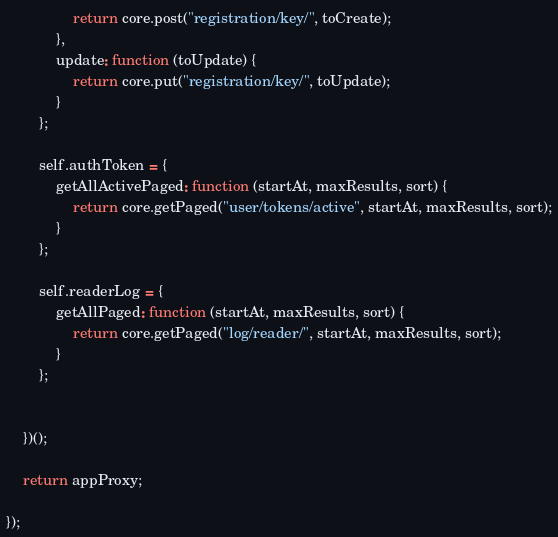Convert code to text. <code><loc_0><loc_0><loc_500><loc_500><_JavaScript_>				return core.post("registration/key/", toCreate);
			},
			update: function (toUpdate) {
				return core.put("registration/key/", toUpdate);
			}
		};
		
		self.authToken = {
			getAllActivePaged: function (startAt, maxResults, sort) {
				return core.getPaged("user/tokens/active", startAt, maxResults, sort);
			}
		};
		
		self.readerLog = {
			getAllPaged: function (startAt, maxResults, sort) {
				return core.getPaged("log/reader/", startAt, maxResults, sort);
			}
		};
				 
		
	})();
	
	return appProxy;
	
});</code> 